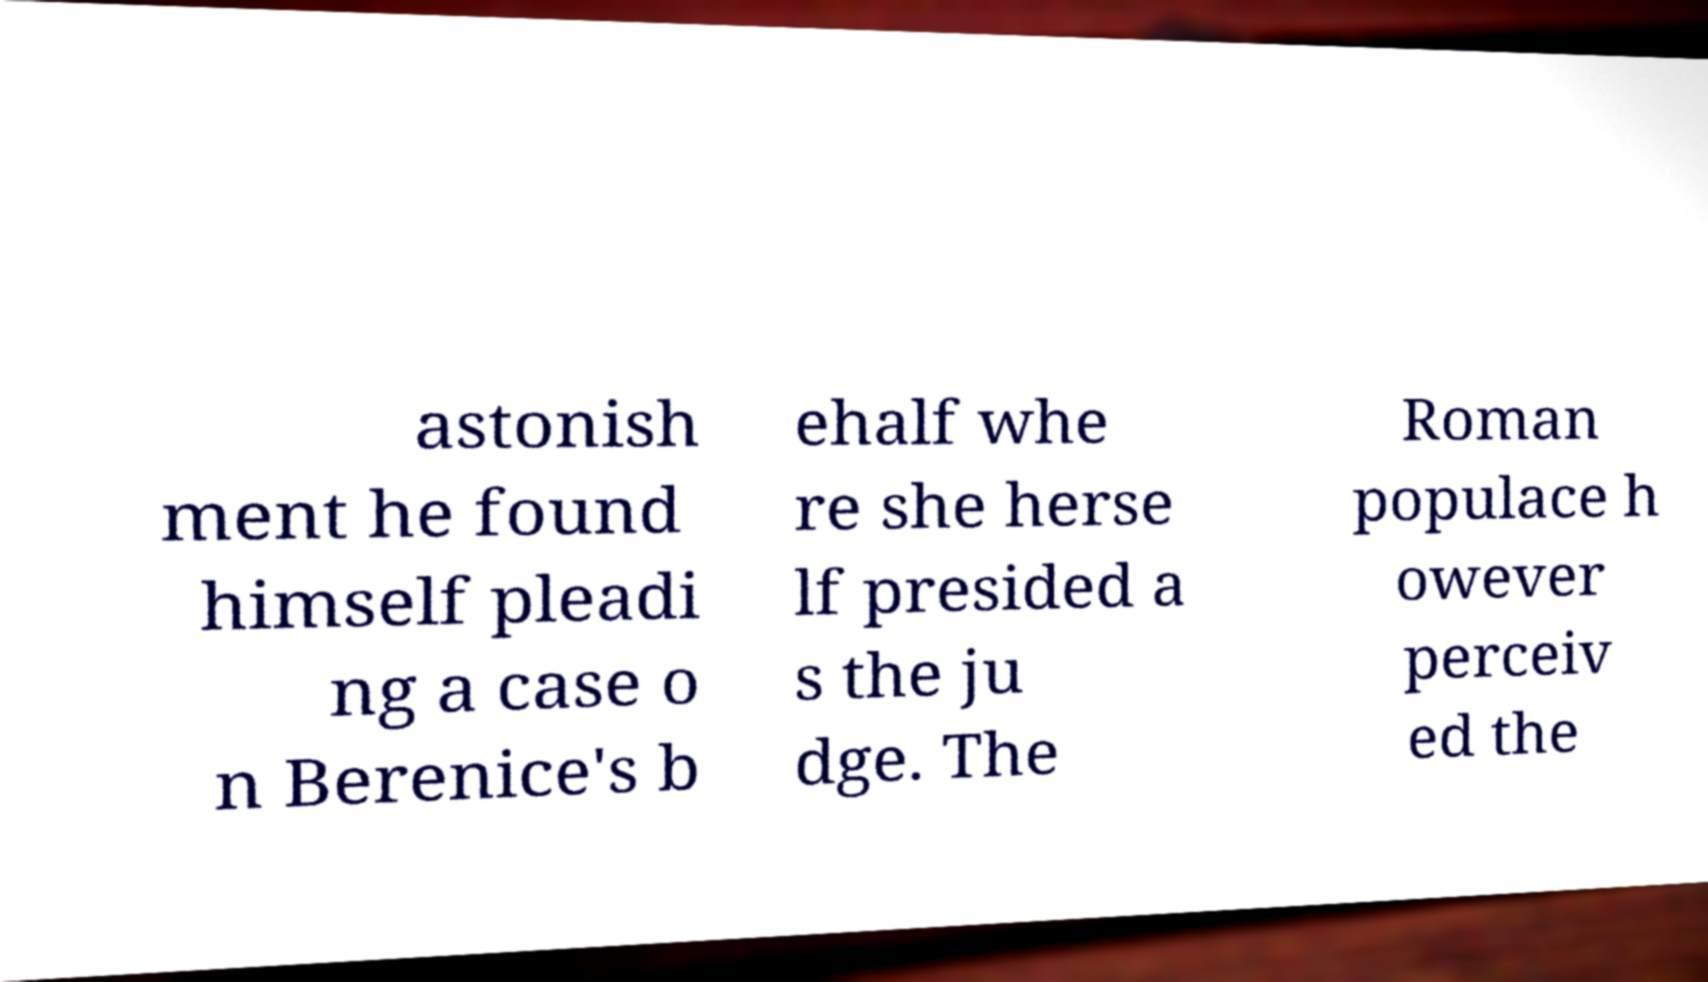Please read and relay the text visible in this image. What does it say? astonish ment he found himself pleadi ng a case o n Berenice's b ehalf whe re she herse lf presided a s the ju dge. The Roman populace h owever perceiv ed the 